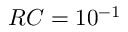<formula> <loc_0><loc_0><loc_500><loc_500>R C = 1 0 ^ { - 1 }</formula> 